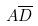Convert formula to latex. <formula><loc_0><loc_0><loc_500><loc_500>A \overline { D }</formula> 